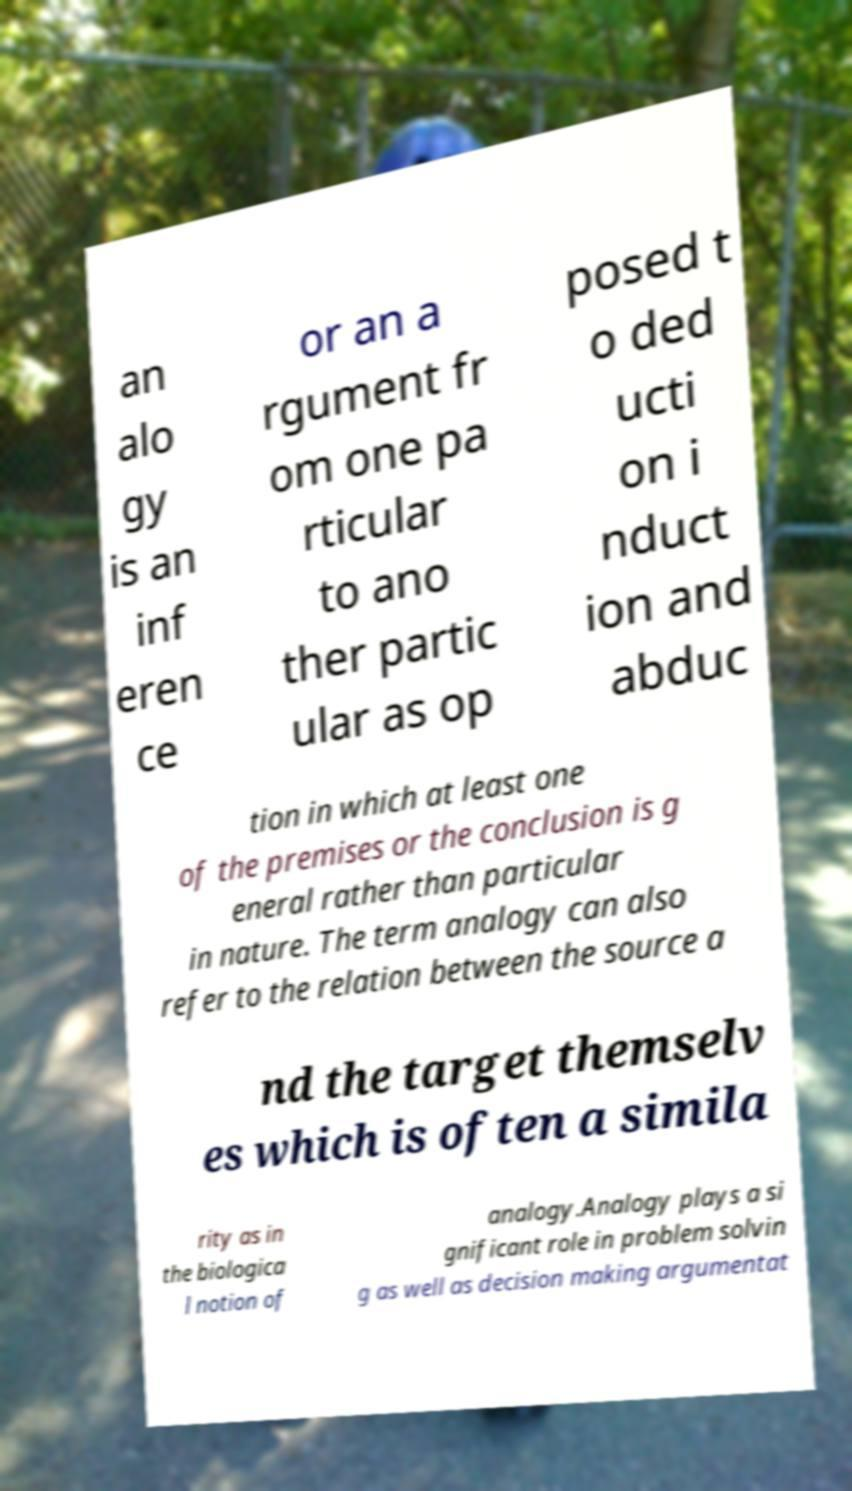What messages or text are displayed in this image? I need them in a readable, typed format. an alo gy is an inf eren ce or an a rgument fr om one pa rticular to ano ther partic ular as op posed t o ded ucti on i nduct ion and abduc tion in which at least one of the premises or the conclusion is g eneral rather than particular in nature. The term analogy can also refer to the relation between the source a nd the target themselv es which is often a simila rity as in the biologica l notion of analogy.Analogy plays a si gnificant role in problem solvin g as well as decision making argumentat 